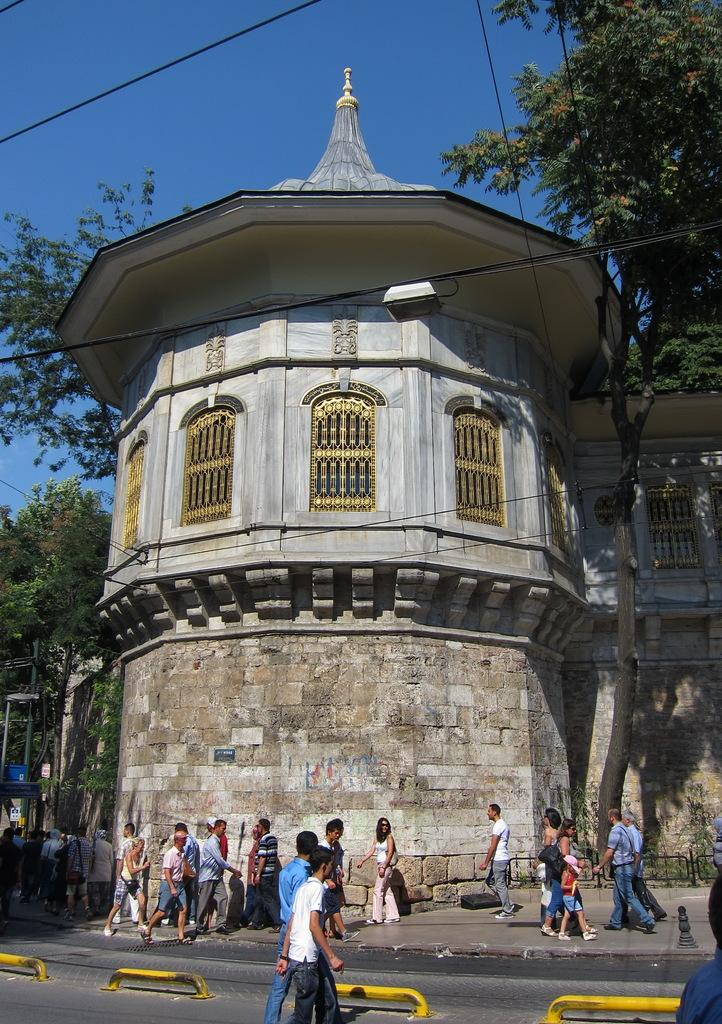What are the people in the image doing? The people in the image are walking on the road. What structure is located beside the road in the image? There is a building beside the road in the image. What type of vegetation is visible in the image? There is a tree visible in the image. What type of weather can be heard in the image? There is no sound or weather mentioned in the image, so it cannot be heard. Can you describe the voice of the tree in the image? Trees do not have voices, so this cannot be described. 